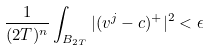Convert formula to latex. <formula><loc_0><loc_0><loc_500><loc_500>\frac { 1 } { ( 2 T ) ^ { n } } \int _ { B _ { 2 T } } | ( v ^ { j } - c ) ^ { + } | ^ { 2 } < \epsilon</formula> 